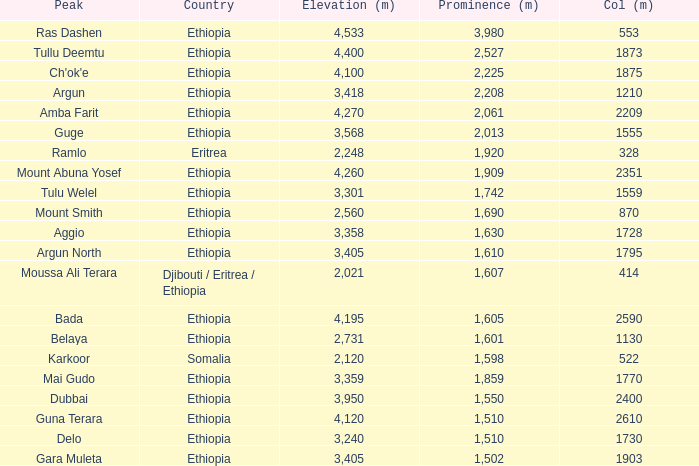How many meters is the prominence of moussa ali terara peak in total? 1607.0. Write the full table. {'header': ['Peak', 'Country', 'Elevation (m)', 'Prominence (m)', 'Col (m)'], 'rows': [['Ras Dashen', 'Ethiopia', '4,533', '3,980', '553'], ['Tullu Deemtu', 'Ethiopia', '4,400', '2,527', '1873'], ["Ch'ok'e", 'Ethiopia', '4,100', '2,225', '1875'], ['Argun', 'Ethiopia', '3,418', '2,208', '1210'], ['Amba Farit', 'Ethiopia', '4,270', '2,061', '2209'], ['Guge', 'Ethiopia', '3,568', '2,013', '1555'], ['Ramlo', 'Eritrea', '2,248', '1,920', '328'], ['Mount Abuna Yosef', 'Ethiopia', '4,260', '1,909', '2351'], ['Tulu Welel', 'Ethiopia', '3,301', '1,742', '1559'], ['Mount Smith', 'Ethiopia', '2,560', '1,690', '870'], ['Aggio', 'Ethiopia', '3,358', '1,630', '1728'], ['Argun North', 'Ethiopia', '3,405', '1,610', '1795'], ['Moussa Ali Terara', 'Djibouti / Eritrea / Ethiopia', '2,021', '1,607', '414'], ['Bada', 'Ethiopia', '4,195', '1,605', '2590'], ['Belaya', 'Ethiopia', '2,731', '1,601', '1130'], ['Karkoor', 'Somalia', '2,120', '1,598', '522'], ['Mai Gudo', 'Ethiopia', '3,359', '1,859', '1770'], ['Dubbai', 'Ethiopia', '3,950', '1,550', '2400'], ['Guna Terara', 'Ethiopia', '4,120', '1,510', '2610'], ['Delo', 'Ethiopia', '3,240', '1,510', '1730'], ['Gara Muleta', 'Ethiopia', '3,405', '1,502', '1903']]} 